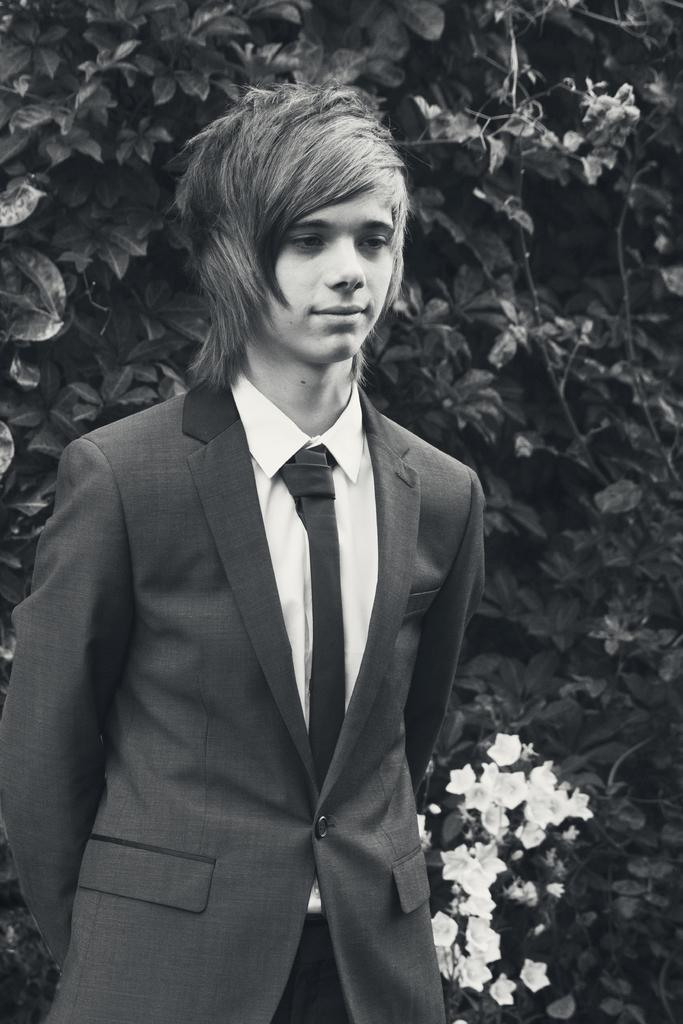What is the color scheme of the image? The image is black and white. What can be seen in the background of the image? There are green leaves and flowers in the background of the image. What is the man in the image wearing? The man is wearing a shirt, a tie, and a blazer. What is the man doing in the image? The man is standing and smiling. How many beds are visible in the image? There are no beds present in the image. What is the angle of the flowers in the image? The image is black and white, so it is not possible to determine the angle of the flowers. 